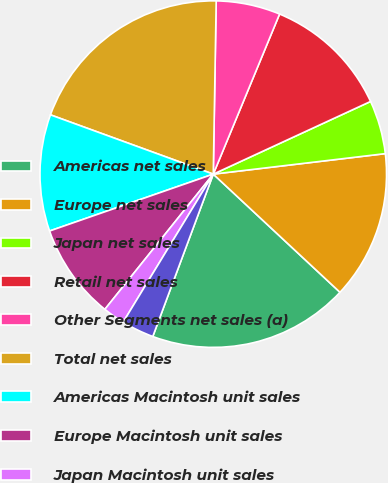Convert chart. <chart><loc_0><loc_0><loc_500><loc_500><pie_chart><fcel>Americas net sales<fcel>Europe net sales<fcel>Japan net sales<fcel>Retail net sales<fcel>Other Segments net sales (a)<fcel>Total net sales<fcel>Americas Macintosh unit sales<fcel>Europe Macintosh unit sales<fcel>Japan Macintosh unit sales<fcel>Retail Macintosh unit sales<nl><fcel>18.73%<fcel>13.83%<fcel>5.0%<fcel>11.86%<fcel>5.98%<fcel>19.71%<fcel>10.88%<fcel>8.92%<fcel>2.05%<fcel>3.03%<nl></chart> 